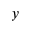<formula> <loc_0><loc_0><loc_500><loc_500>y</formula> 